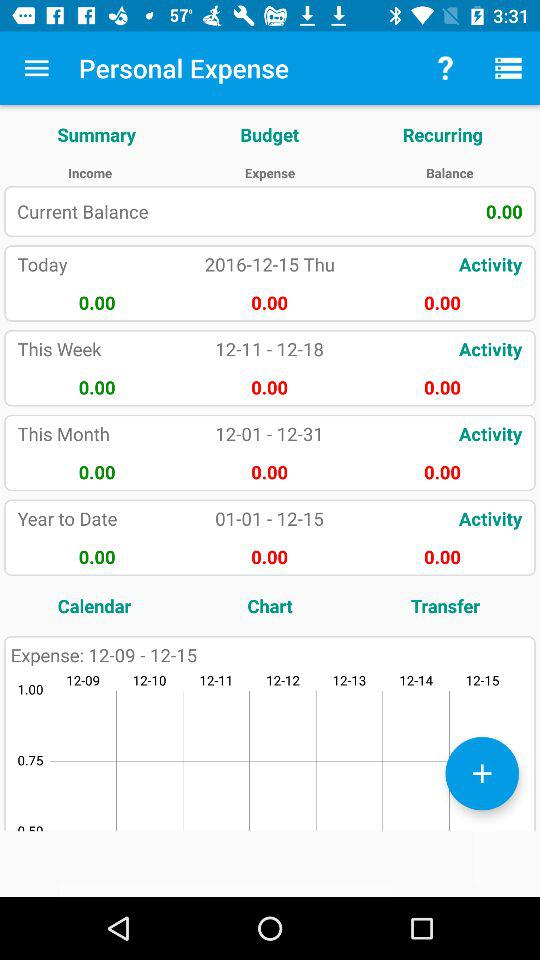What is today's date? Today's date is Thursday, December 15, 2016. 